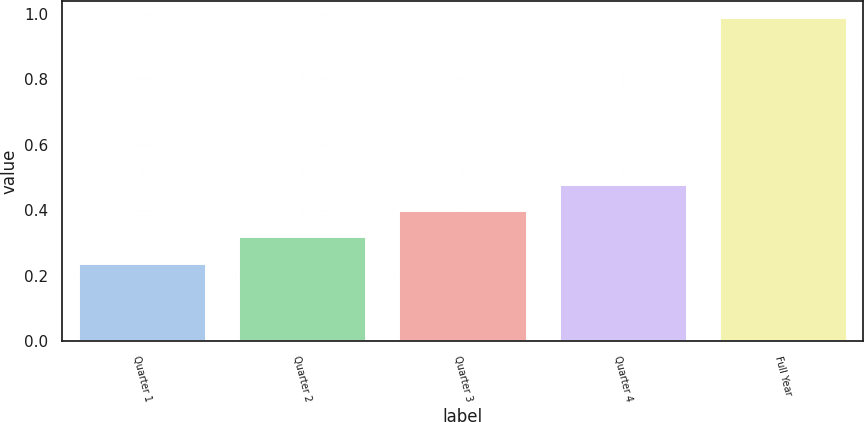Convert chart. <chart><loc_0><loc_0><loc_500><loc_500><bar_chart><fcel>Quarter 1<fcel>Quarter 2<fcel>Quarter 3<fcel>Quarter 4<fcel>Full Year<nl><fcel>0.24<fcel>0.32<fcel>0.4<fcel>0.48<fcel>0.99<nl></chart> 